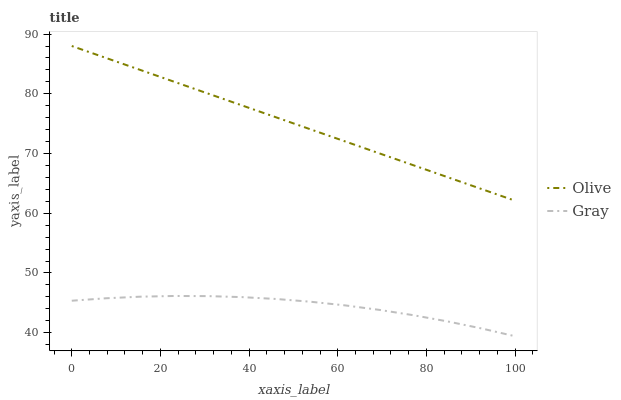Does Gray have the minimum area under the curve?
Answer yes or no. Yes. Does Olive have the maximum area under the curve?
Answer yes or no. Yes. Does Gray have the maximum area under the curve?
Answer yes or no. No. Is Olive the smoothest?
Answer yes or no. Yes. Is Gray the roughest?
Answer yes or no. Yes. Is Gray the smoothest?
Answer yes or no. No. Does Gray have the lowest value?
Answer yes or no. Yes. Does Olive have the highest value?
Answer yes or no. Yes. Does Gray have the highest value?
Answer yes or no. No. Is Gray less than Olive?
Answer yes or no. Yes. Is Olive greater than Gray?
Answer yes or no. Yes. Does Gray intersect Olive?
Answer yes or no. No. 